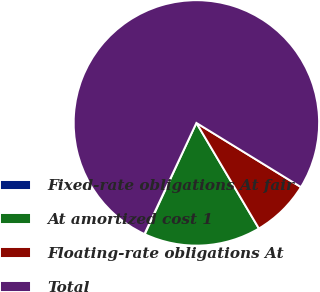Convert chart to OTSL. <chart><loc_0><loc_0><loc_500><loc_500><pie_chart><fcel>Fixed-rate obligations At fair<fcel>At amortized cost 1<fcel>Floating-rate obligations At<fcel>Total<nl><fcel>0.06%<fcel>15.41%<fcel>7.73%<fcel>76.81%<nl></chart> 